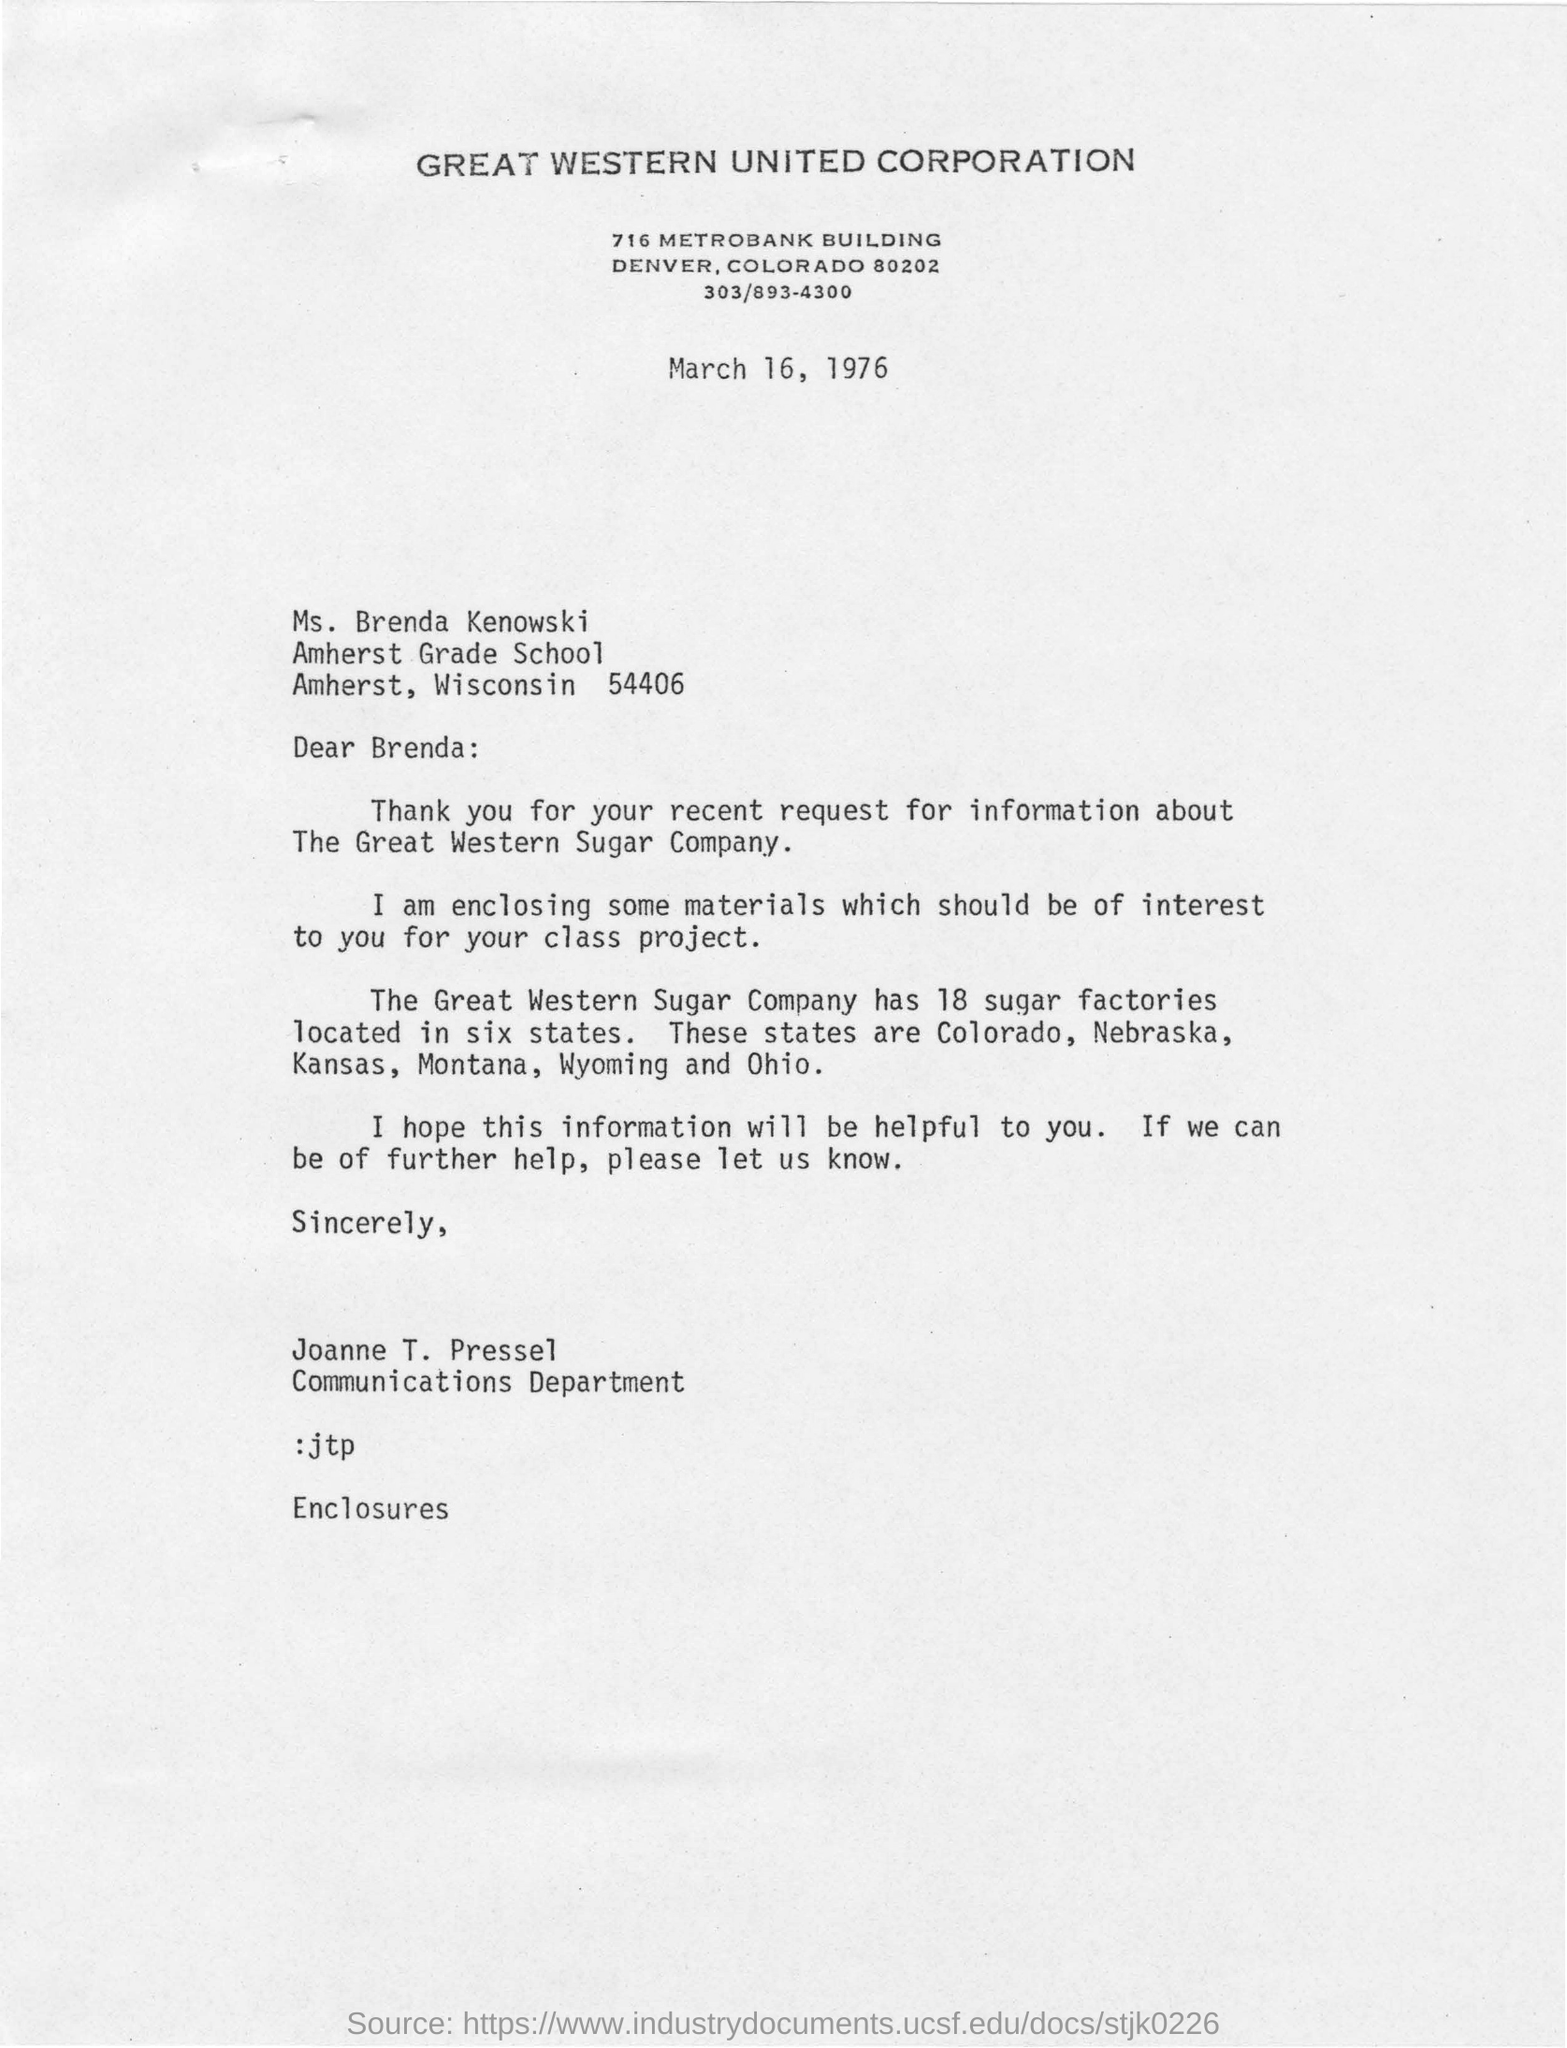What is the name of the corporation ?
Provide a succinct answer. Great western united corporation. To whom this letter was written ?
Provide a short and direct response. Brenda. What is the information enclosed in the letter ?
Give a very brief answer. Some materials which should be of interest to you for your class project. How many sugar factories are located in six states that belongs to great western sugar company ?
Your response must be concise. 18. To which department joanne t.pressel belongs to ?
Make the answer very short. Communications department. What is the information requested in the recent request ?
Give a very brief answer. About the great western sugar company. 